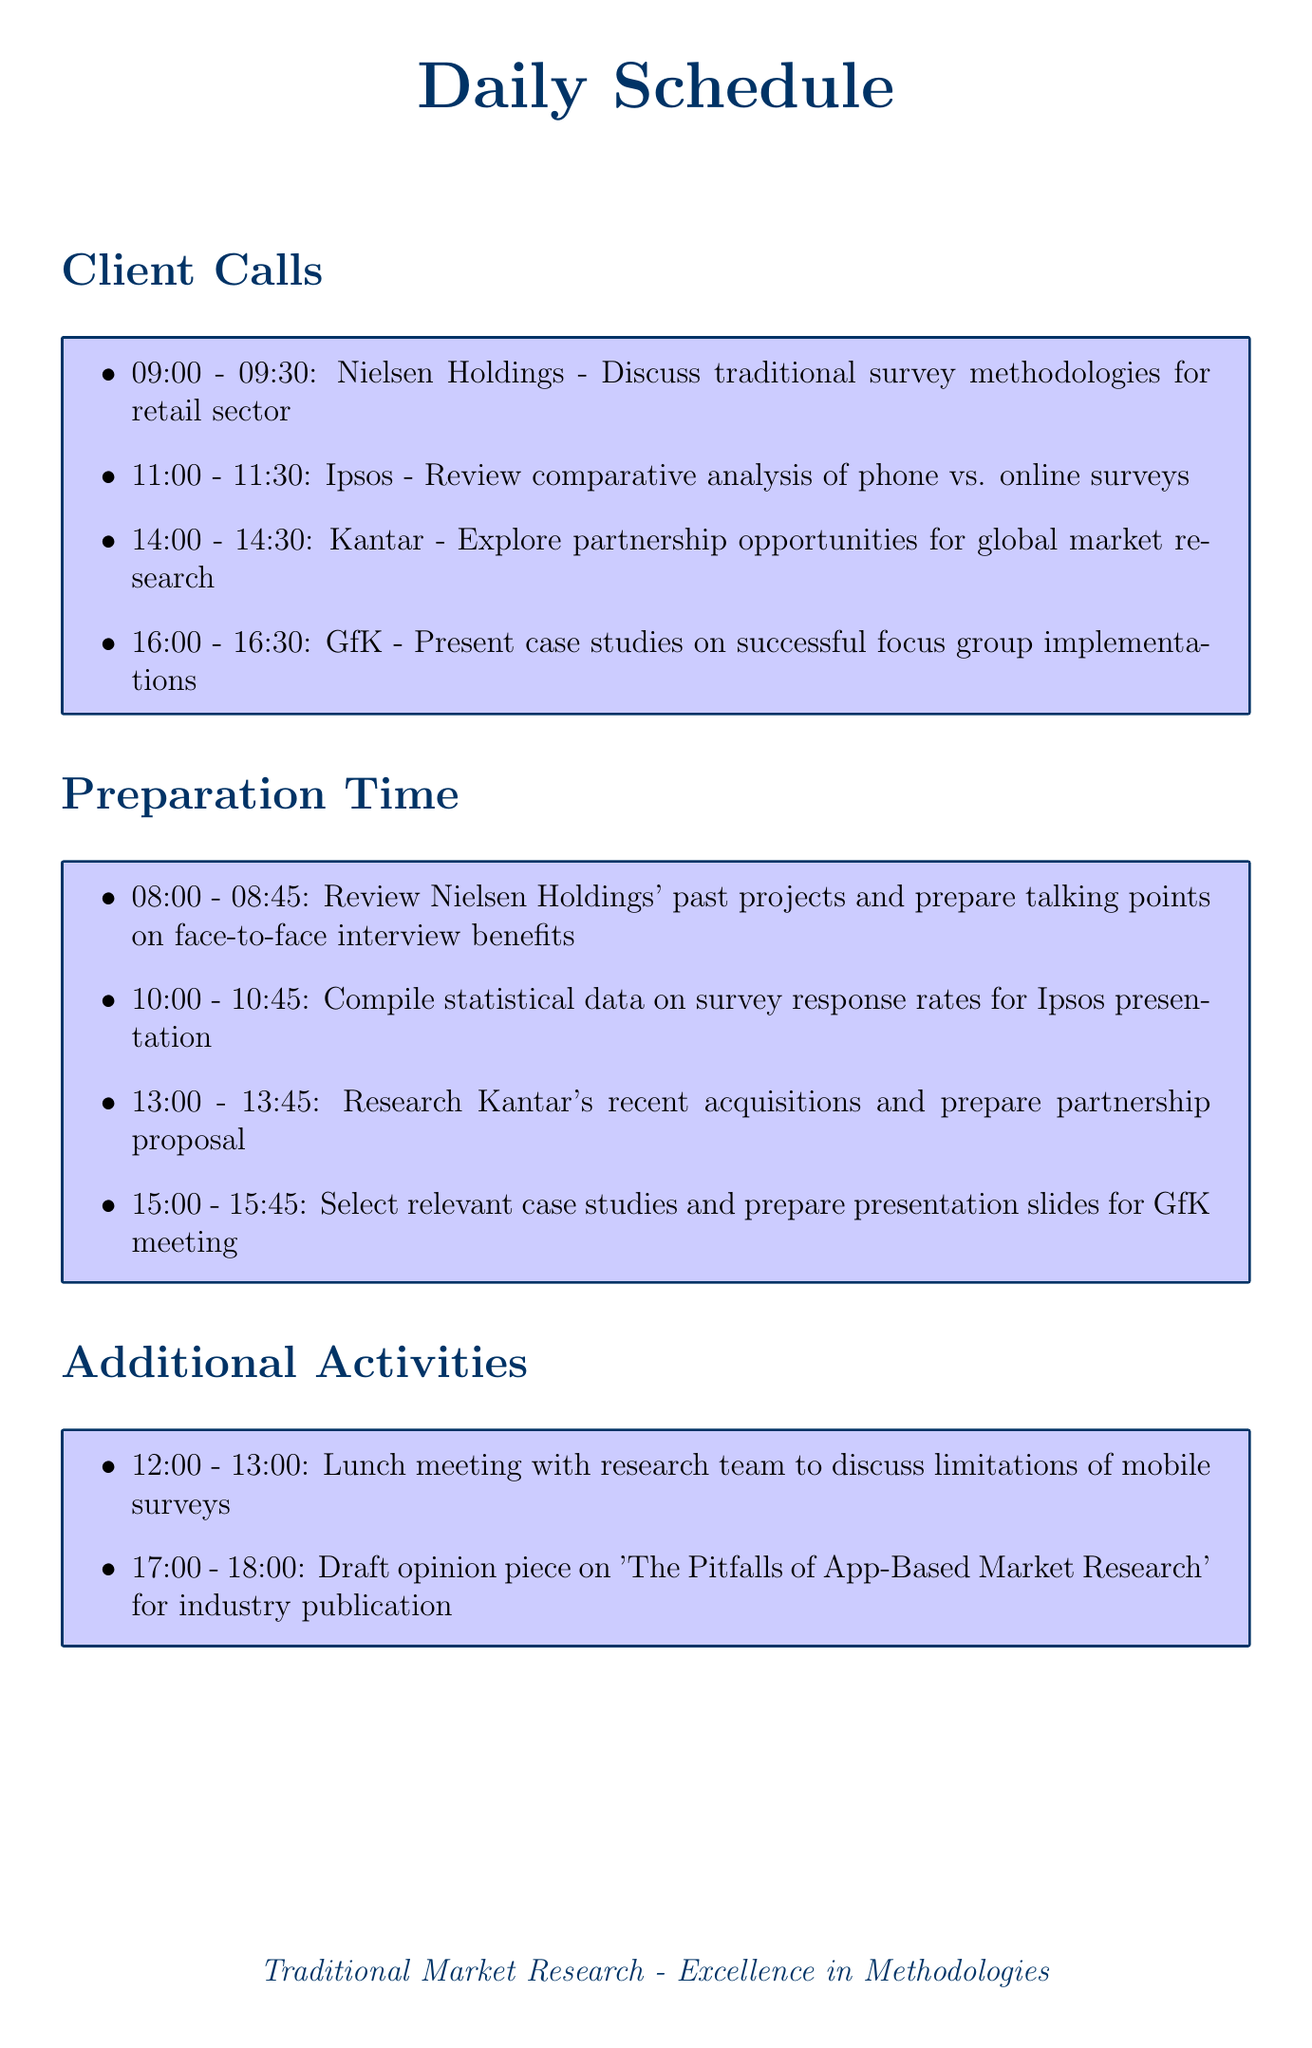What time is the call with Nielsen Holdings? The scheduled time for the call with Nielsen Holdings is listed in the document.
Answer: 09:00 - 09:30 What is the purpose of the call with Ipsos? The purpose of the call with Ipsos is provided in the document under client calls.
Answer: Review comparative analysis of phone vs. online surveys What activity is scheduled right before the meeting with Kantar? The document lists preparation activities, which provide insight into what is scheduled before which meetings.
Answer: Research Kantar's recent acquisitions and prepare partnership proposal How long does each client call last? The duration of each client call is consistent and can be inferred from the times given in the document.
Answer: 30 minutes What time is the lunch meeting scheduled? The document provides specific times for all additional activities, including the lunch meeting.
Answer: 12:00 - 13:00 What is one key focus to emphasize during client interactions? The document mentions reminders that outline priorities for client interactions.
Answer: Depth and accuracy of traditional research methods How many preparation time blocks are listed in the document? The document clearly lists the preparation time blocks; counting them gives the answer.
Answer: Four What is the last activity scheduled for the day? The order of activities is listed in the document, revealing which one comes last.
Answer: Draft opinion piece on 'The Pitfalls of App-Based Market Research' for industry publication 